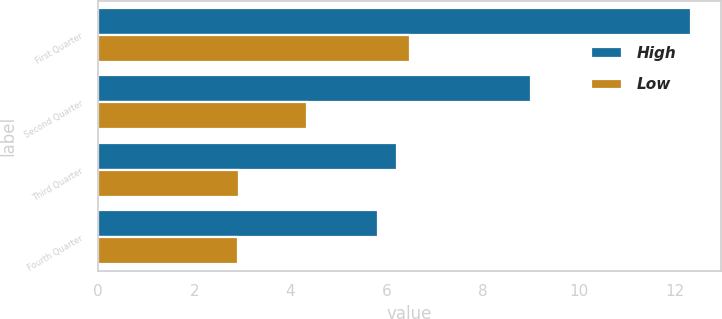Convert chart. <chart><loc_0><loc_0><loc_500><loc_500><stacked_bar_chart><ecel><fcel>First Quarter<fcel>Second Quarter<fcel>Third Quarter<fcel>Fourth Quarter<nl><fcel>High<fcel>12.34<fcel>9<fcel>6.22<fcel>5.83<nl><fcel>Low<fcel>6.5<fcel>4.34<fcel>2.93<fcel>2.91<nl></chart> 